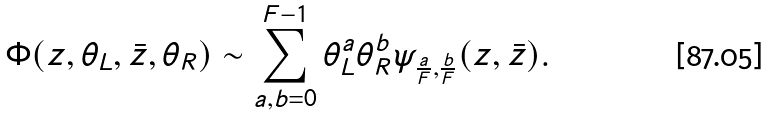Convert formula to latex. <formula><loc_0><loc_0><loc_500><loc_500>\Phi ( z , \theta _ { L } , \bar { z } , \theta _ { R } ) \sim \sum _ { a , b = 0 } ^ { F - 1 } \theta _ { L } ^ { a } \theta _ { R } ^ { b } \psi _ { \frac { a } { F } , \frac { b } { F } } ( z , \bar { z } ) .</formula> 